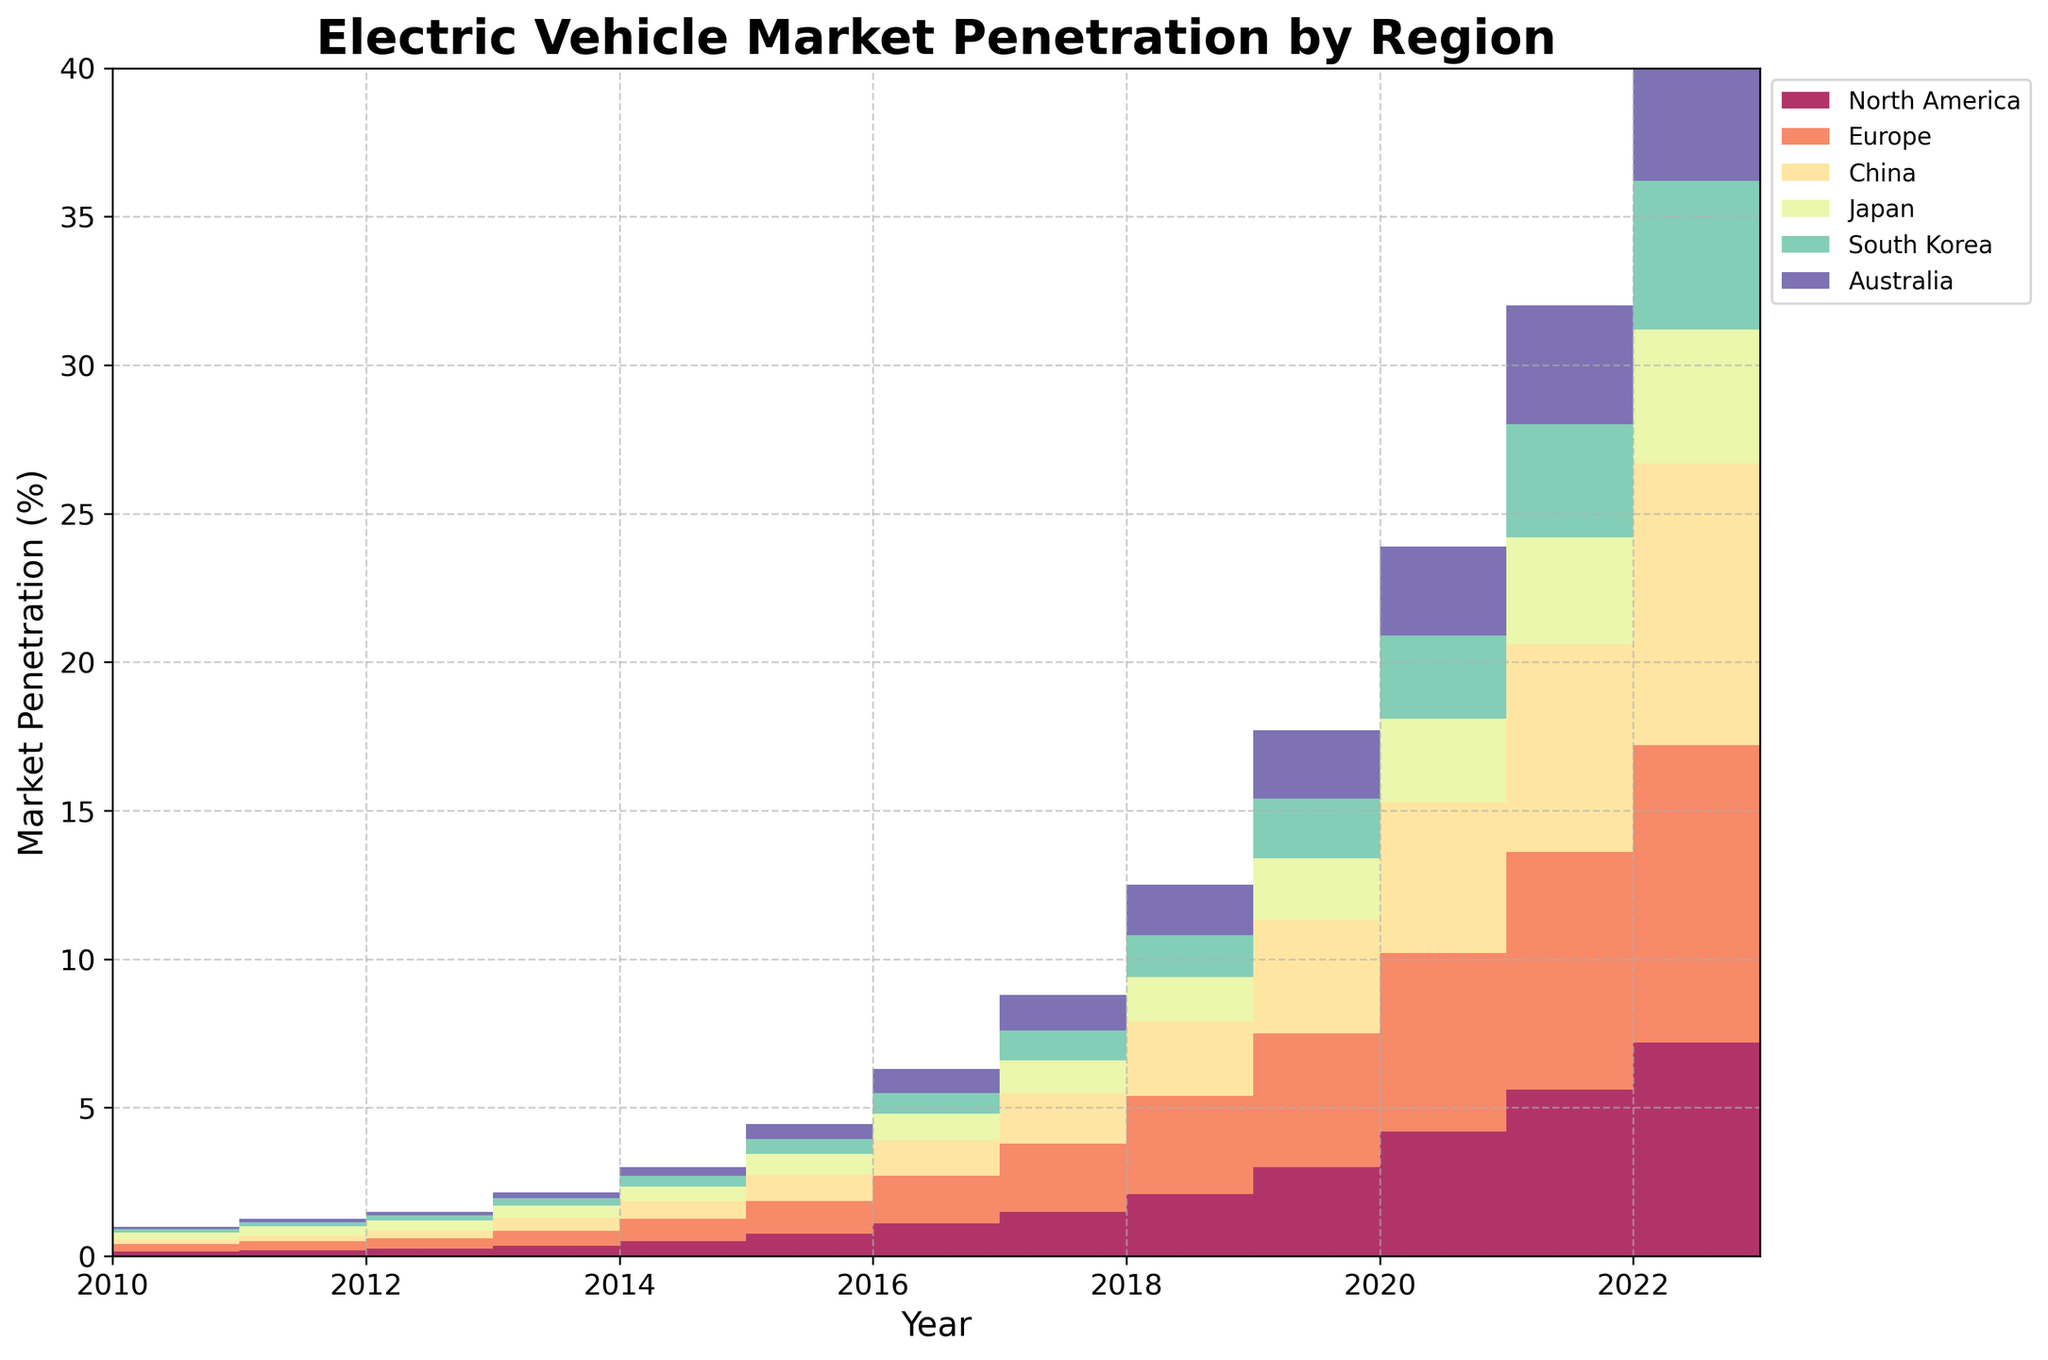What is the title of the chart? The title of the chart is at the top and it reads "Electric Vehicle Market Penetration by Region".
Answer: Electric Vehicle Market Penetration by Region Which geographic region had the highest market penetration in 2023? Referring to the chart, the region with the highest market penetration in 2023 is the one with the largest vertical segment. Europe has the highest market penetration.
Answer: Europe What was the market penetration percentage for North America in 2018? To find this, locate the 2018 mark on the x-axis and check the corresponding value for North America. North America achieved a market penetration of approximately 1.5%.
Answer: 1.5% How many regions are represented in the chart? Count the number of different colored areas in the chart. There are six regions represented in the chart.
Answer: 6 What is the total market penetration for all regions combined in 2020? To find the total market penetration in 2020, sum the values for all regions: 3.0 + 4.5 + 3.8 + 2.1 + 2.0 + 2.3 = 17.7.
Answer: 17.7% Between which years did China experience its highest growth in market penetration? To identify the highest growth, observe the steepest increase in the step area for China. The steepest increase occurred between 2021 and 2022.
Answer: 2021 to 2022 Which region had the slowest market penetration growth from 2010 to 2023? Compare the growth slopes of all regions. Japan shows a slower growth rate compared to others.
Answer: Japan What is the difference in market penetration between Europe and Australia in 2023? Find the values for Europe and Australia in 2023 and subtract Australia's market penetration from Europe's: 10.0 - 5.2 = 4.8.
Answer: 4.8% What is the average market penetration for South Korea over the years? Average is the sum of values divided by the number of years. Sum all values for South Korea and divide by the number of years: (0.1+0.12+0.15+0.18+0.25+0.35+0.5+0.7+1.0+1.4+2.0+2.8+3.8+5.0) / 14 ≈ 1.825%.
Answer: 1.825% By how much did the market penetration for Australia increase from 2015 to 2023? Check the values for Australia in 2015 and 2023 and find their difference: 5.2 - 0.3 = 4.9.
Answer: 4.9% 